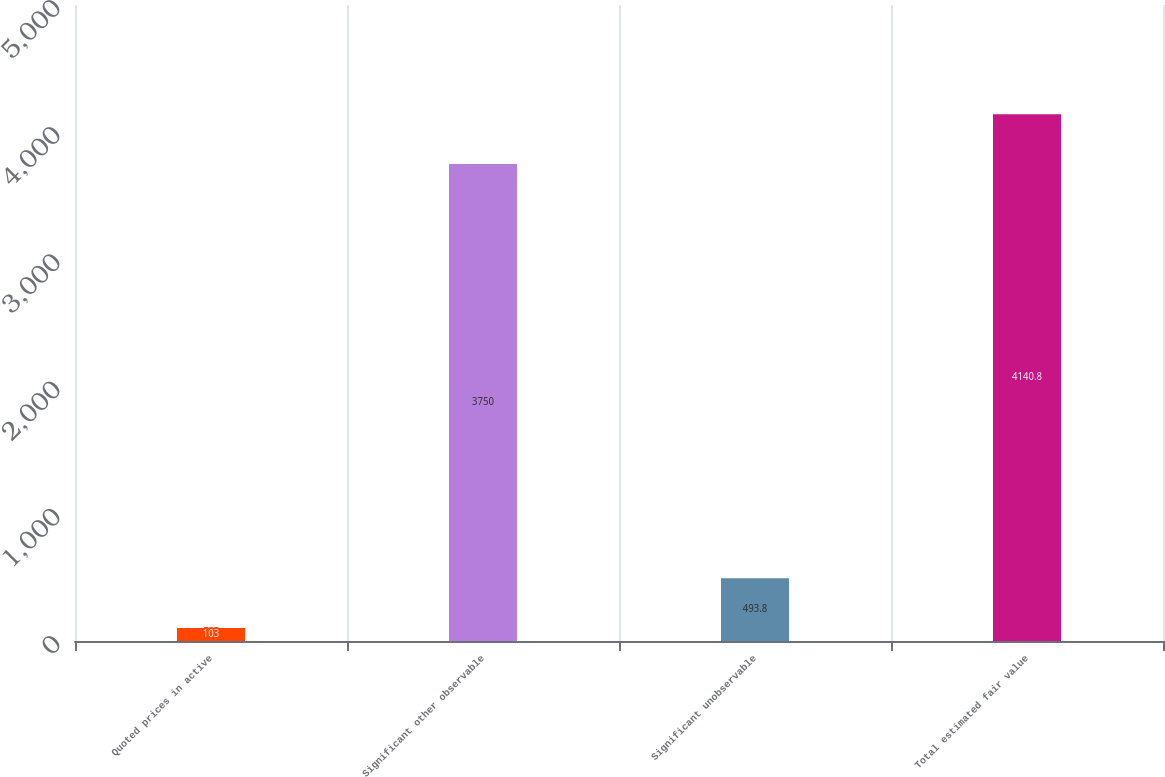Convert chart. <chart><loc_0><loc_0><loc_500><loc_500><bar_chart><fcel>Quoted prices in active<fcel>Significant other observable<fcel>Significant unobservable<fcel>Total estimated fair value<nl><fcel>103<fcel>3750<fcel>493.8<fcel>4140.8<nl></chart> 